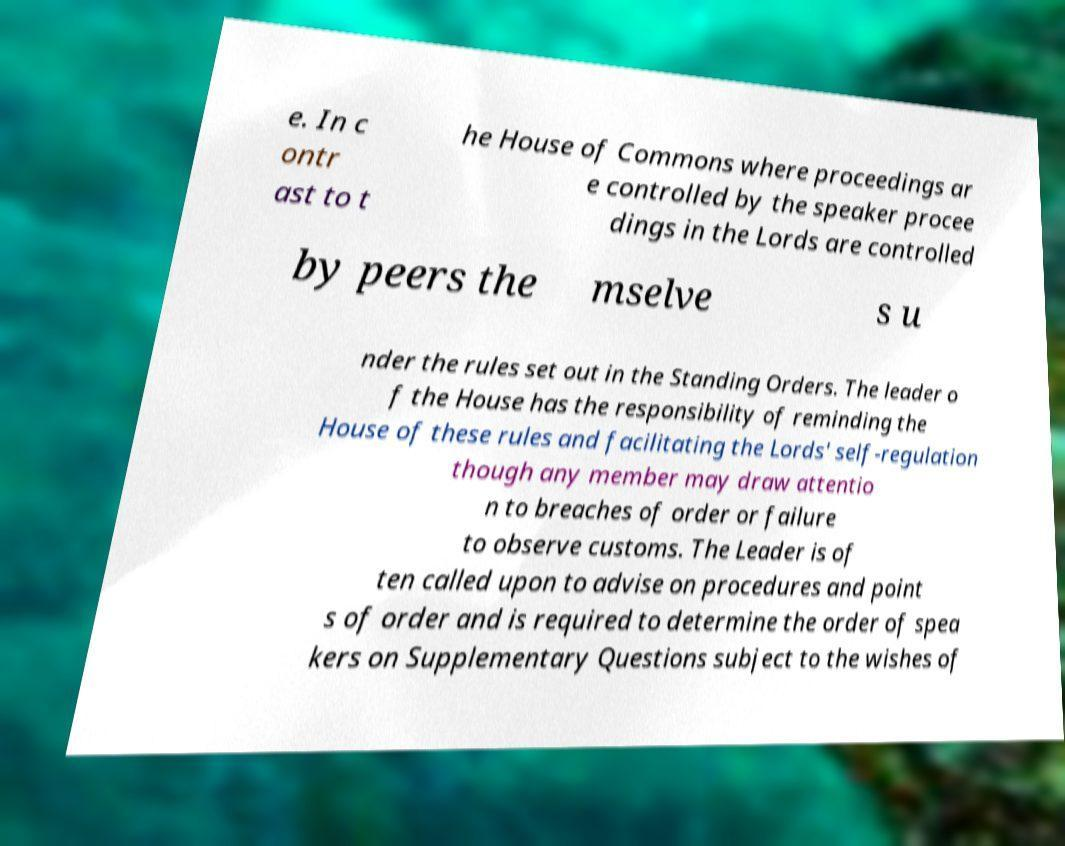I need the written content from this picture converted into text. Can you do that? e. In c ontr ast to t he House of Commons where proceedings ar e controlled by the speaker procee dings in the Lords are controlled by peers the mselve s u nder the rules set out in the Standing Orders. The leader o f the House has the responsibility of reminding the House of these rules and facilitating the Lords' self-regulation though any member may draw attentio n to breaches of order or failure to observe customs. The Leader is of ten called upon to advise on procedures and point s of order and is required to determine the order of spea kers on Supplementary Questions subject to the wishes of 